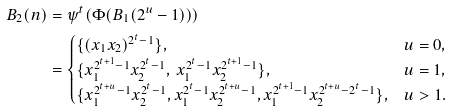Convert formula to latex. <formula><loc_0><loc_0><loc_500><loc_500>B _ { 2 } ( n ) & = \psi ^ { t } ( \Phi ( B _ { 1 } ( 2 ^ { u } - 1 ) ) ) \\ & = \begin{cases} \{ ( x _ { 1 } x _ { 2 } ) ^ { 2 ^ { t } - 1 } \} , & u = 0 , \\ \{ x _ { 1 } ^ { 2 ^ { t + 1 } - 1 } x _ { 2 } ^ { 2 ^ { t } - 1 } , \ x _ { 1 } ^ { 2 ^ { t } - 1 } x _ { 2 } ^ { 2 ^ { t + 1 } - 1 } \} , \ & u = 1 , \\ \{ x _ { 1 } ^ { 2 ^ { t + u } - 1 } x _ { 2 } ^ { 2 ^ { t } - 1 } , x _ { 1 } ^ { 2 ^ { t } - 1 } x _ { 2 } ^ { 2 ^ { t + u } - 1 } , x _ { 1 } ^ { 2 ^ { t + 1 } - 1 } x _ { 2 } ^ { 2 ^ { t + u } - 2 ^ { t } - 1 } \} , & u > 1 . \end{cases}</formula> 